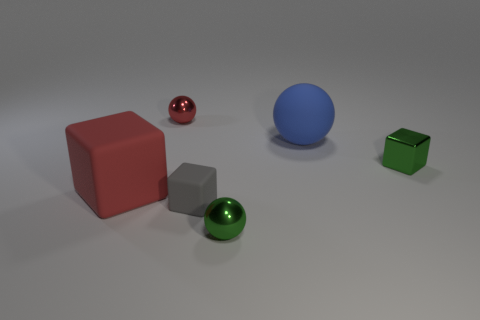Add 1 big green metallic cubes. How many objects exist? 7 Add 3 small green shiny objects. How many small green shiny objects exist? 5 Subtract 0 purple spheres. How many objects are left? 6 Subtract all tiny red metal objects. Subtract all cyan matte balls. How many objects are left? 5 Add 1 metal objects. How many metal objects are left? 4 